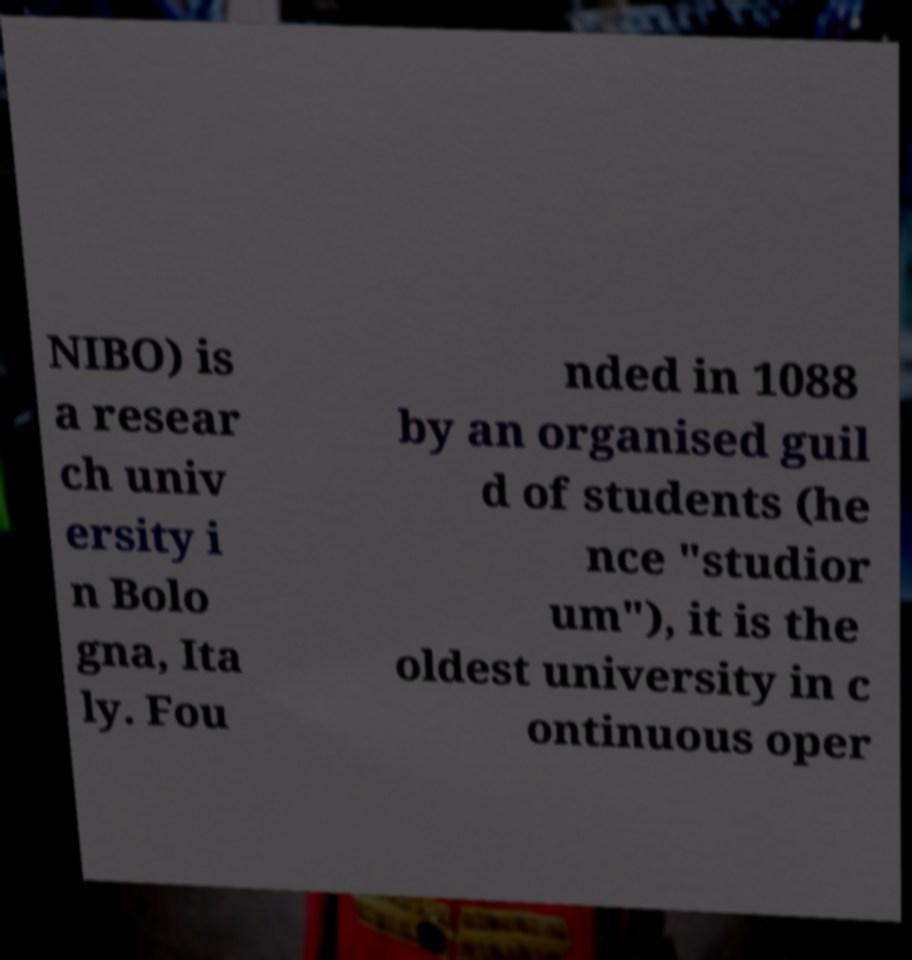Can you read and provide the text displayed in the image?This photo seems to have some interesting text. Can you extract and type it out for me? NIBO) is a resear ch univ ersity i n Bolo gna, Ita ly. Fou nded in 1088 by an organised guil d of students (he nce "studior um"), it is the oldest university in c ontinuous oper 